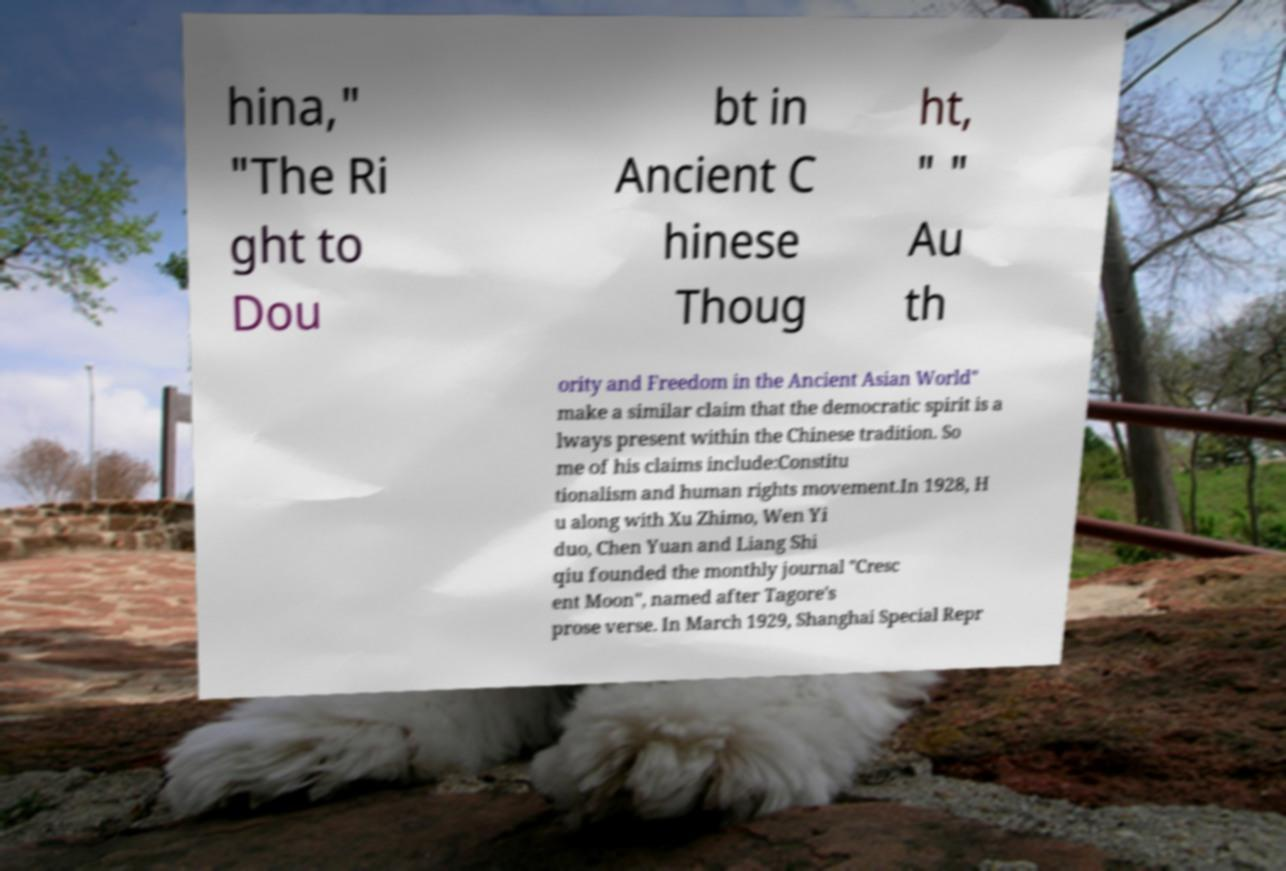Can you accurately transcribe the text from the provided image for me? hina," "The Ri ght to Dou bt in Ancient C hinese Thoug ht, " " Au th ority and Freedom in the Ancient Asian World" make a similar claim that the democratic spirit is a lways present within the Chinese tradition. So me of his claims include:Constitu tionalism and human rights movement.In 1928, H u along with Xu Zhimo, Wen Yi duo, Chen Yuan and Liang Shi qiu founded the monthly journal "Cresc ent Moon", named after Tagore's prose verse. In March 1929, Shanghai Special Repr 